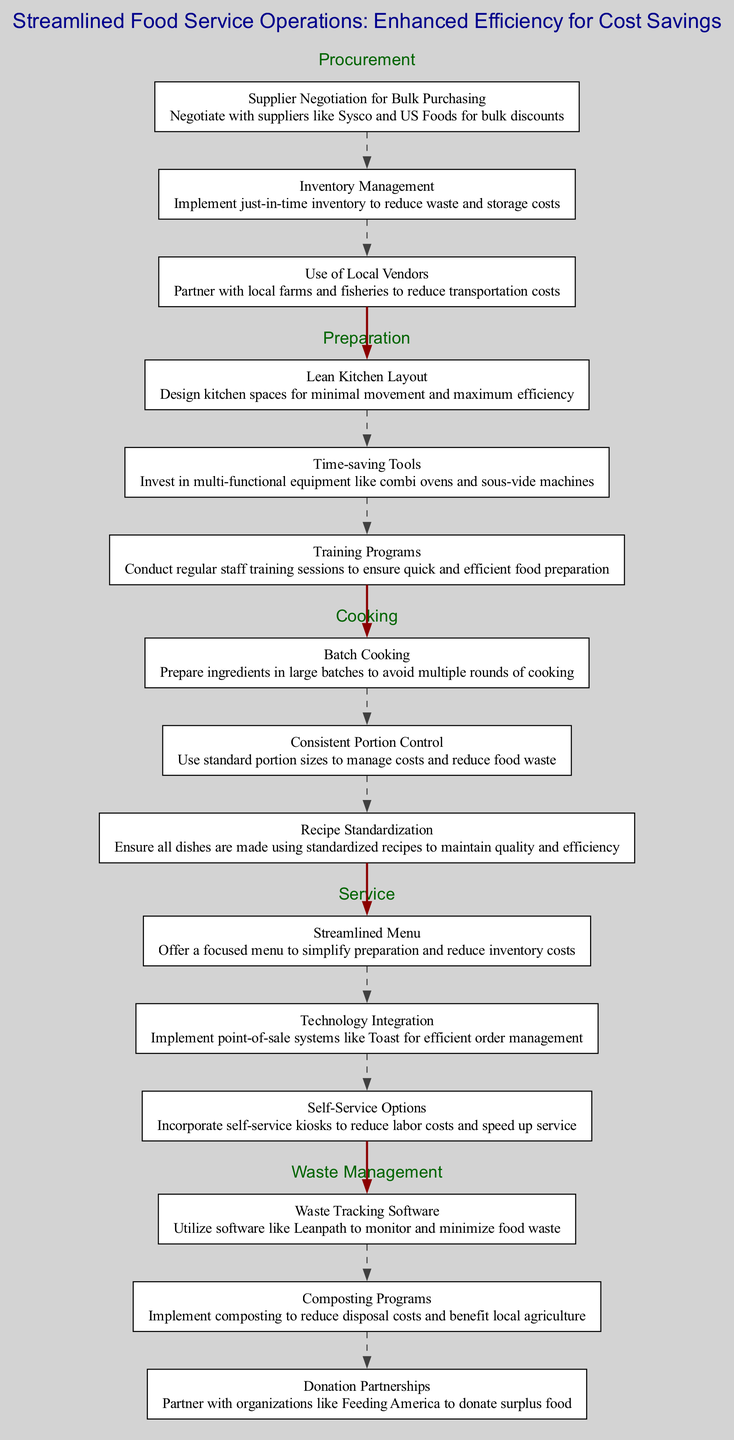What are the three main stages in the diagram? The diagram outlines five stages: Procurement, Preparation, Cooking, Service, and Waste Management.
Answer: Procurement, Preparation, Cooking, Service, Waste Management How many actions are listed under the Preparation stage? There are three actions listed under the Preparation stage: Lean Kitchen Layout, Time-saving Tools, and Training Programs.
Answer: 3 What action is included in the Service stage that involves technology? The action listed in the Service stage that involves technology is Technology Integration.
Answer: Technology Integration Which stage includes an action related to Waste Tracking Software? The stage that includes an action related to Waste Tracking Software is Waste Management.
Answer: Waste Management What is the first action in the Cooking stage? The first action listed in the Cooking stage is Batch Cooking.
Answer: Batch Cooking How does the Waste Management stage connect to the Service stage? The Waste Management stage connects to the Service stage through the last action in Waste Management leading to the first action in Service.
Answer: Last action in Waste Management to first action in Service What is a common goal across all stages of the clinical pathway? The common goal across all stages is enhanced efficiency for cost savings.
Answer: Enhanced efficiency for cost savings Which action under Procurement aims to reduce waste? The action under Procurement that aims to reduce waste is Inventory Management.
Answer: Inventory Management How many actions are dedicated to waste in the Waste Management stage? There are three actions dedicated to waste in the Waste Management stage.
Answer: 3 